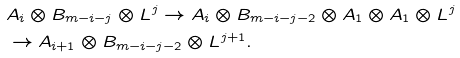Convert formula to latex. <formula><loc_0><loc_0><loc_500><loc_500>& A _ { i } \otimes B _ { m - i - j } \otimes L ^ { j } \to A _ { i } \otimes B _ { m - i - j - 2 } \otimes A _ { 1 } \otimes A _ { 1 } \otimes L ^ { j } \\ & \to A _ { i + 1 } \otimes B _ { m - i - j - 2 } \otimes L ^ { j + 1 } .</formula> 